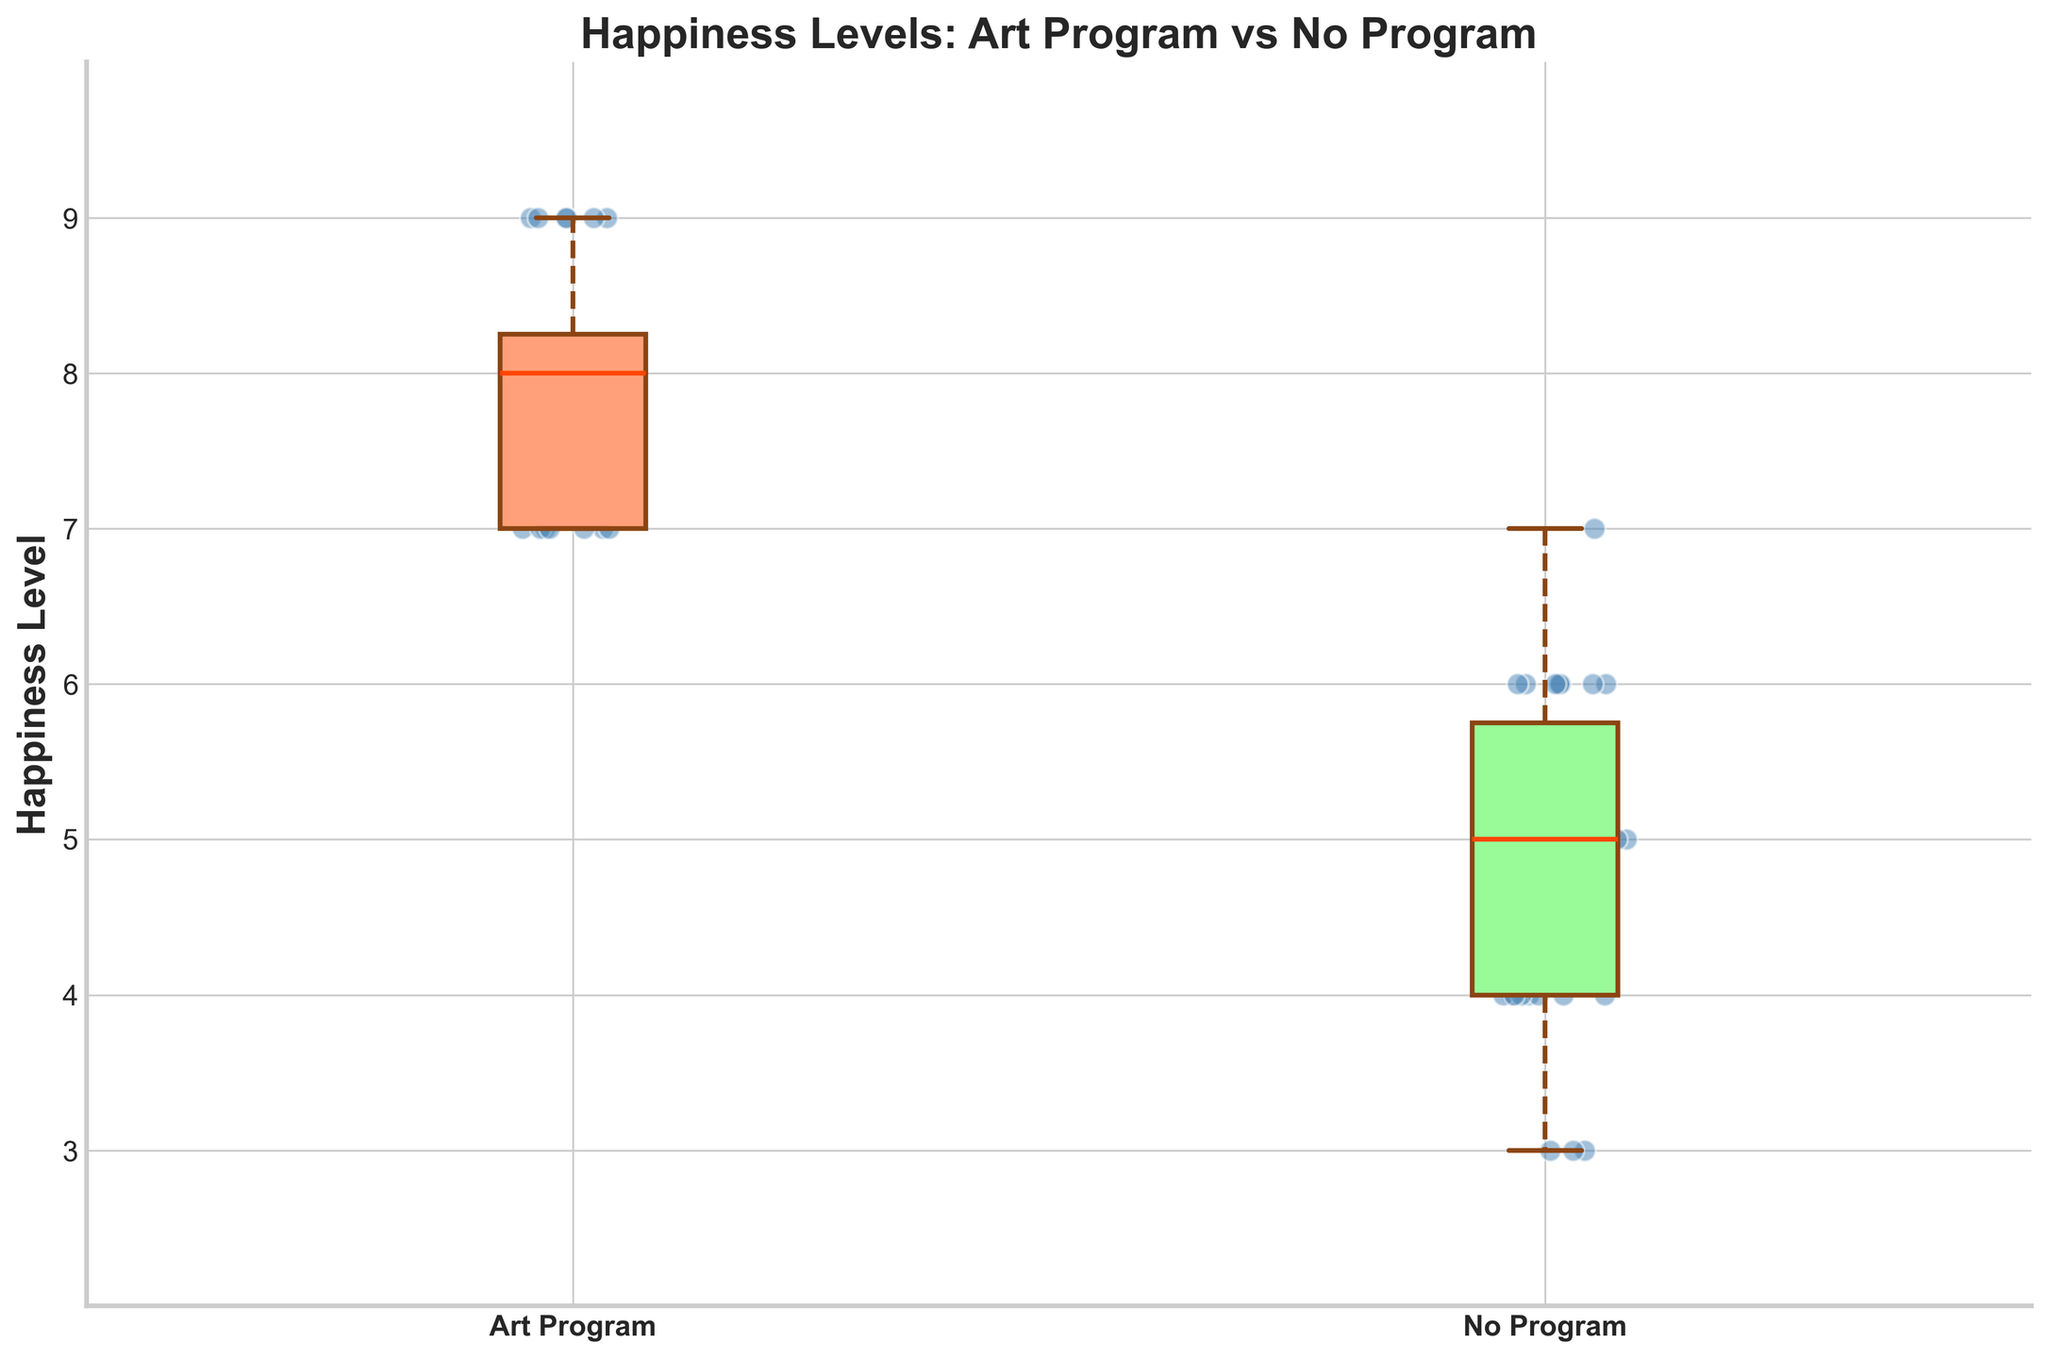What's the title of the figure? The title of the figure is located at the top and is bolded for emphasis. It provides an overview of what the figure is representing.
Answer: Happiness Levels: Art Program vs No Program What is the median happiness level of families in art programs? The median is represented by a horizontal line inside the box. For families in art programs, it is the line within the box on the left.
Answer: 8 Which group has a higher median happiness level, Art Program or No Program? By comparing the positions of the median lines inside the boxes, we see that the median line for the Art Program is at 8, while for the No Program it is at 5.
Answer: Art Program What is the range of happiness levels for families not involved in any programs? The range is determined by the difference between the highest and lowest points of the whiskers. For families in the No Program group, the whiskers extend from 3 to 7.
Answer: 4 How many scatter points are there for families in the art program on the figure? Each scatter point represents a data point. To find the number of scatter points, count the individual points over the box of the Art Program.
Answer: 22 What are the whisker lengths representing in terms of happiness levels for families involved in art programs? The whiskers represent the range from the smallest to the largest value, excluding outliers. For families in the art program, the whiskers extend from 7 to 9.
Answer: 2 Which group shows more variation in happiness levels, judging by the box plot width? Variation can be assessed by the interquartile range (IQR), which is represented by the width of the box. The No Program group's box is wider, indicating more variation.
Answer: No Program What is the interquartile range (IQR) of happiness levels for families not involved in art programs? The interquartile range (IQR) is the difference between the third quartile (Q3) and the first quartile (Q1). For the No Program group, Q3 is 6 and Q1 is 4.
Answer: 2 Does any group have outliers, and if so, which one? Outliers would be individual points outside the whiskers. By examining both groups, we do not see any individual points that qualify as outliers outside the whisker ranges.
Answer: No Comparing the two groups, which has a higher overall average happiness level? The overall average can be visually estimated, but careful consideration of the median and spread must be used. The Art Program has a higher median and seems to cluster around higher values overall.
Answer: Art Program 